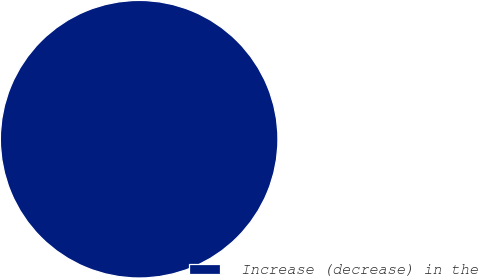<chart> <loc_0><loc_0><loc_500><loc_500><pie_chart><fcel>Increase (decrease) in the<nl><fcel>100.0%<nl></chart> 